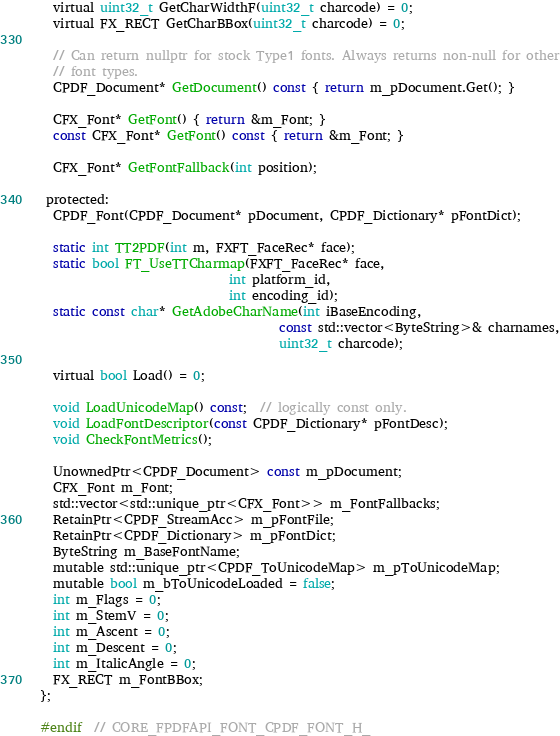Convert code to text. <code><loc_0><loc_0><loc_500><loc_500><_C_>  virtual uint32_t GetCharWidthF(uint32_t charcode) = 0;
  virtual FX_RECT GetCharBBox(uint32_t charcode) = 0;

  // Can return nullptr for stock Type1 fonts. Always returns non-null for other
  // font types.
  CPDF_Document* GetDocument() const { return m_pDocument.Get(); }

  CFX_Font* GetFont() { return &m_Font; }
  const CFX_Font* GetFont() const { return &m_Font; }

  CFX_Font* GetFontFallback(int position);

 protected:
  CPDF_Font(CPDF_Document* pDocument, CPDF_Dictionary* pFontDict);

  static int TT2PDF(int m, FXFT_FaceRec* face);
  static bool FT_UseTTCharmap(FXFT_FaceRec* face,
                              int platform_id,
                              int encoding_id);
  static const char* GetAdobeCharName(int iBaseEncoding,
                                      const std::vector<ByteString>& charnames,
                                      uint32_t charcode);

  virtual bool Load() = 0;

  void LoadUnicodeMap() const;  // logically const only.
  void LoadFontDescriptor(const CPDF_Dictionary* pFontDesc);
  void CheckFontMetrics();

  UnownedPtr<CPDF_Document> const m_pDocument;
  CFX_Font m_Font;
  std::vector<std::unique_ptr<CFX_Font>> m_FontFallbacks;
  RetainPtr<CPDF_StreamAcc> m_pFontFile;
  RetainPtr<CPDF_Dictionary> m_pFontDict;
  ByteString m_BaseFontName;
  mutable std::unique_ptr<CPDF_ToUnicodeMap> m_pToUnicodeMap;
  mutable bool m_bToUnicodeLoaded = false;
  int m_Flags = 0;
  int m_StemV = 0;
  int m_Ascent = 0;
  int m_Descent = 0;
  int m_ItalicAngle = 0;
  FX_RECT m_FontBBox;
};

#endif  // CORE_FPDFAPI_FONT_CPDF_FONT_H_
</code> 